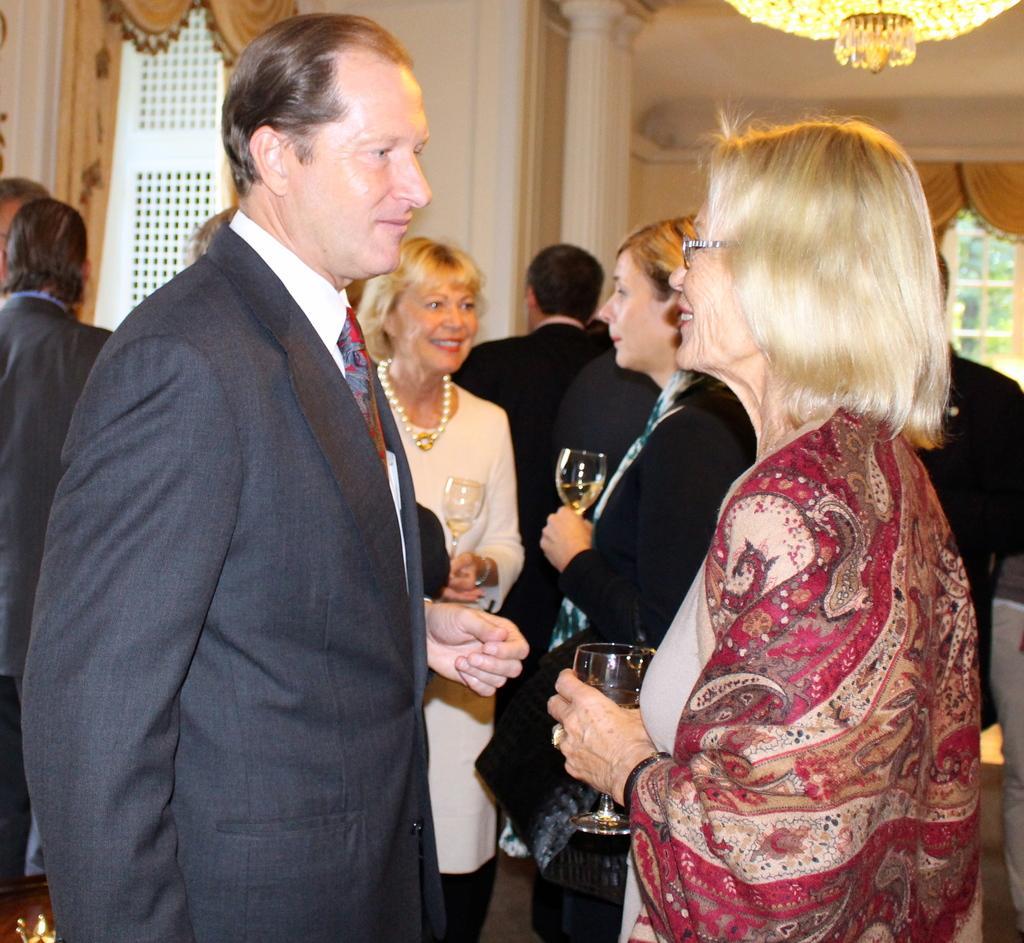Describe this image in one or two sentences. In this picture there is a man who is wearing suit, beside him there is a woman who is holding a wine glass. In the back there are two women were also holding a wine glasses. On the left there are two person were standing near to the door. In the top right corner I can see the chandeliers. On the right, through the window I can see some trees and plants. In the bottom right there is a man who is standing near to the chair. 